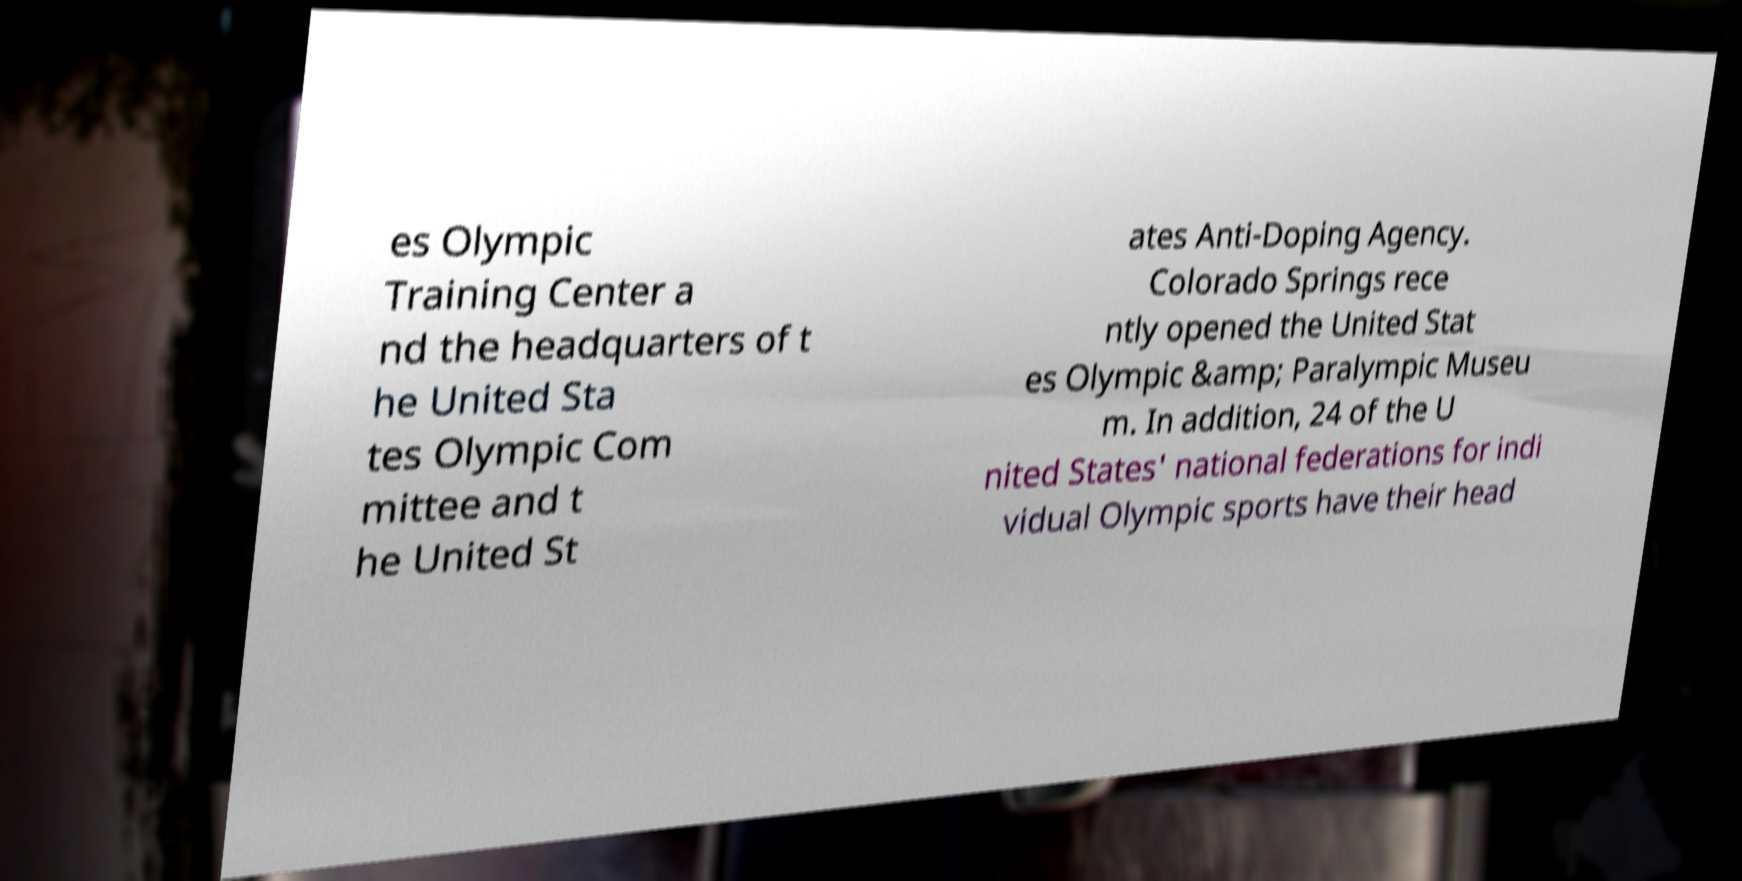Could you assist in decoding the text presented in this image and type it out clearly? es Olympic Training Center a nd the headquarters of t he United Sta tes Olympic Com mittee and t he United St ates Anti-Doping Agency. Colorado Springs rece ntly opened the United Stat es Olympic &amp; Paralympic Museu m. In addition, 24 of the U nited States' national federations for indi vidual Olympic sports have their head 